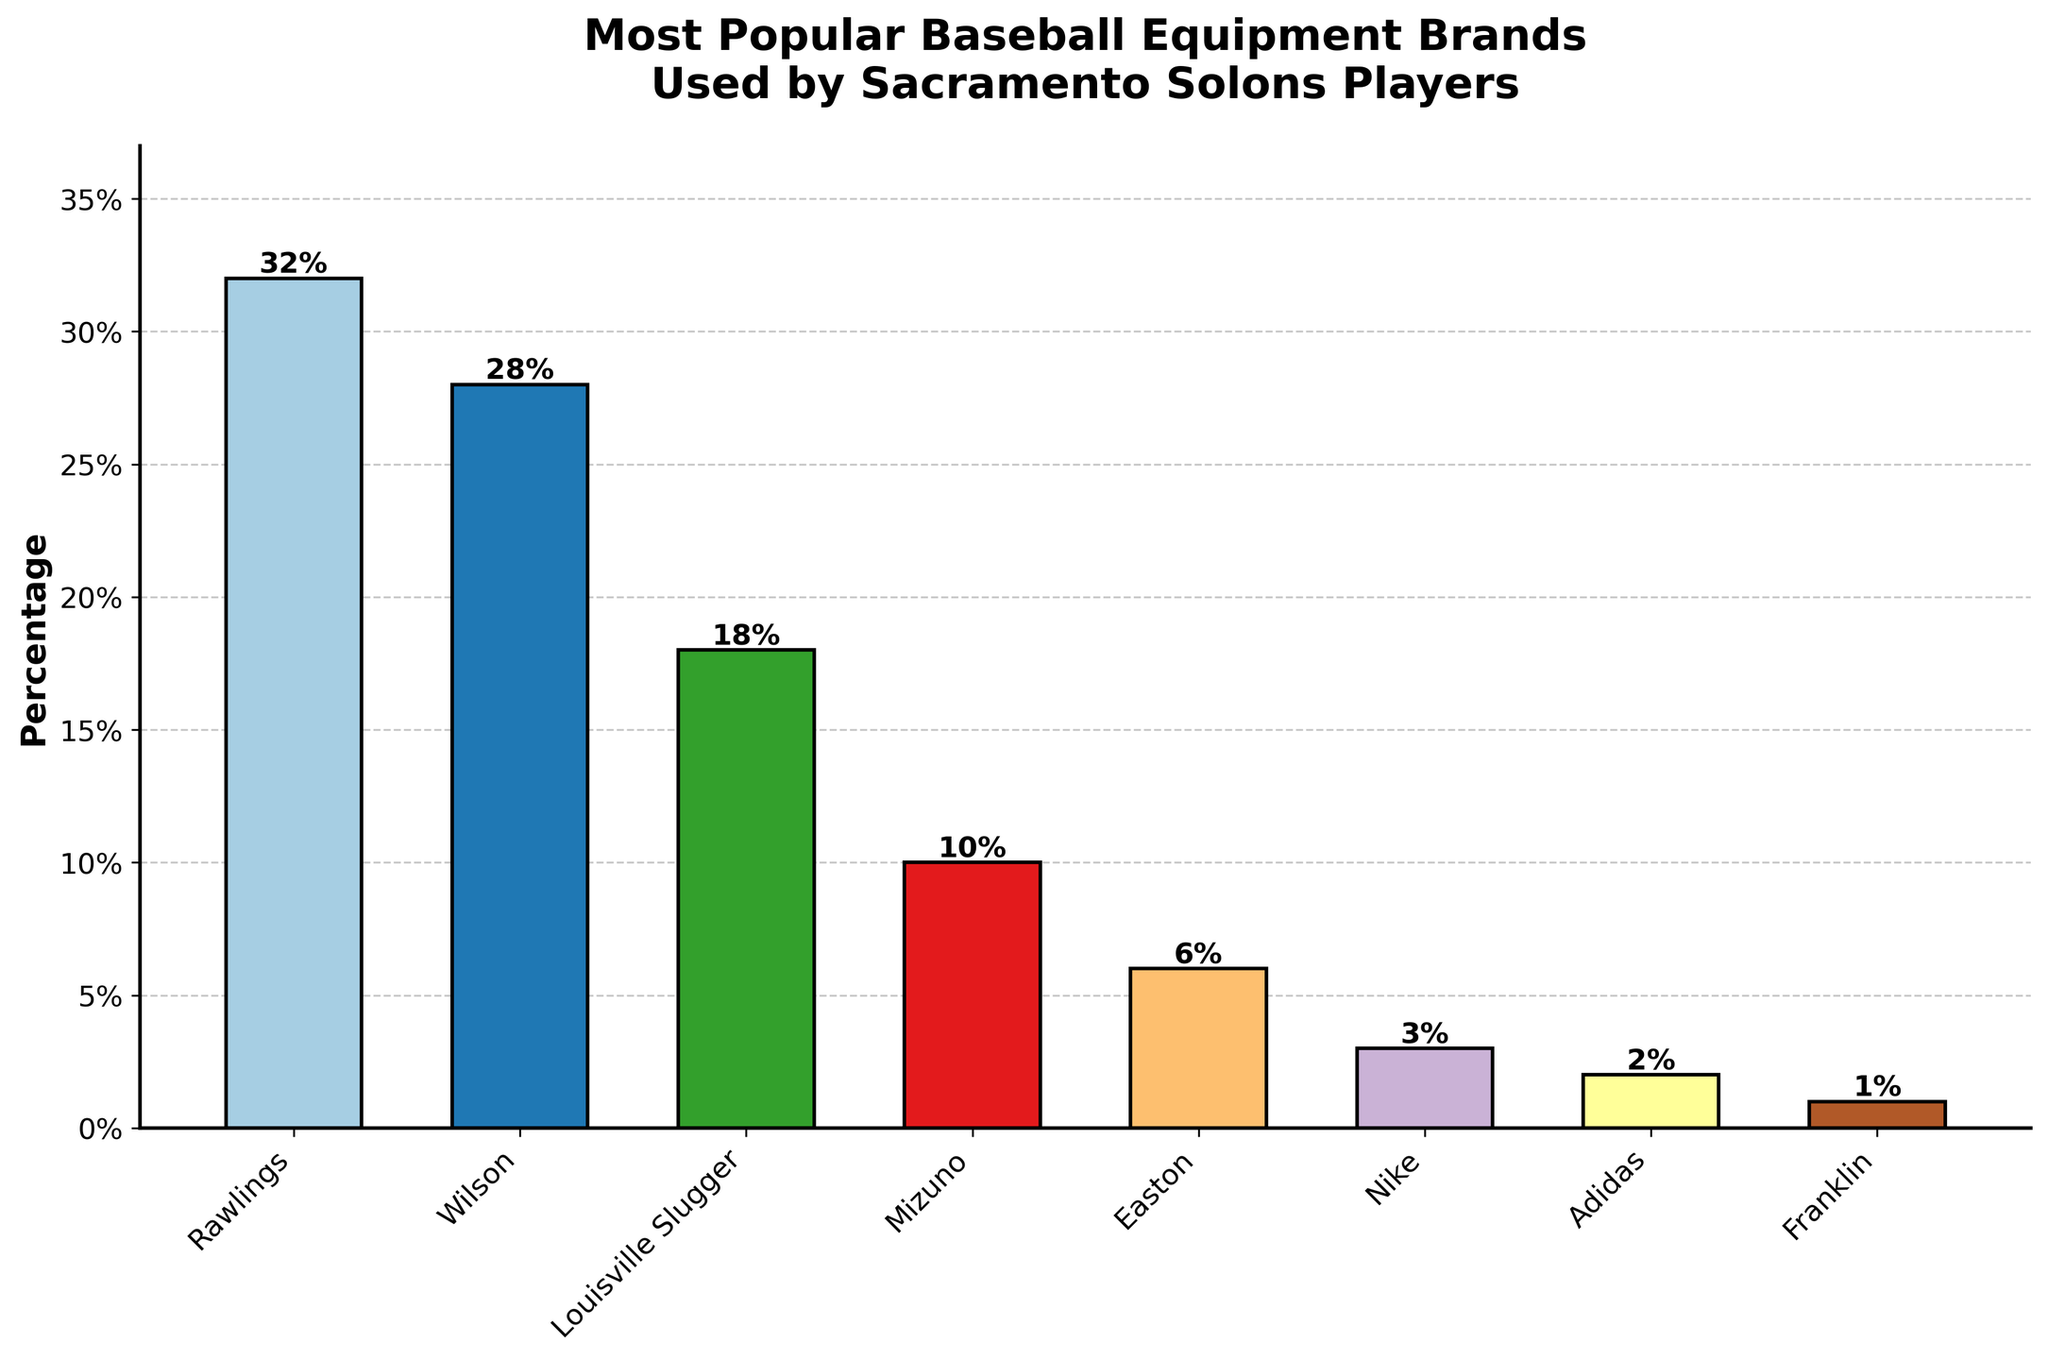How many brands have a percentage higher than 20%? There are three brands with a percentage higher than 20%: Rawlings (32%), Wilson (28%), and Louisville Slugger (18%).
Answer: 2 Which brand has the lowest percentage? By examining the bar heights, Franklin has the lowest percentage (1%).
Answer: Franklin What is the cumulative percentage of the brands Rawlings, Wilson, and Louisville Slugger? Adding the percentages of Rawlings (32%), Wilson (28%), and Louisville Slugger (18%) results in 32 + 28 + 18 = 78%.
Answer: 78% By how much is Rawlings' percentage greater than Nike's percentage? Rawlings has a percentage of 32% and Nike has 3%. The difference is 32 - 3 = 29%.
Answer: 29% Which brands have a percentage equal to or less than 10%? Observing the bar heights, the brands with percentages equal to or less than 10% are Mizuno (10%), Easton (6%), Nike (3%), Adidas (2%), and Franklin (1%).
Answer: Mizuno, Easton, Nike, Adidas, Franklin What's the average percentage of the top three most popular brands? The percentages of the top three brands are Rawlings (32%), Wilson (28%), and Louisville Slugger (18%). The sum is 32 + 28 + 18 = 78%. The average is 78 / 3 = 26%.
Answer: 26% Which brand has a percentage of 6%? Examining the bar heights and labels, Easton has a percentage of 6%.
Answer: Easton What is the combined percentage of Mizuno, Nike, and Adidas? The percentages of Mizuno (10%), Nike (3%), and Adidas (2%) are summed as 10 + 3 + 2 = 15%.
Answer: 15% Which brand has the second-highest percentage? By comparing bar heights, Wilson has the second-highest percentage (28%).
Answer: Wilson Is the percentage of Louisville Slugger closer to that of Wilson or Mizuno? The percentage of Louisville Slugger is 18%, Wilson is 28%, and Mizuno is 10%. The difference between Louisville Slugger and Wilson is 28 - 18 = 10%, while the difference between Louisville Slugger and Mizuno is 18 - 10 = 8%.
Answer: Mizuno 